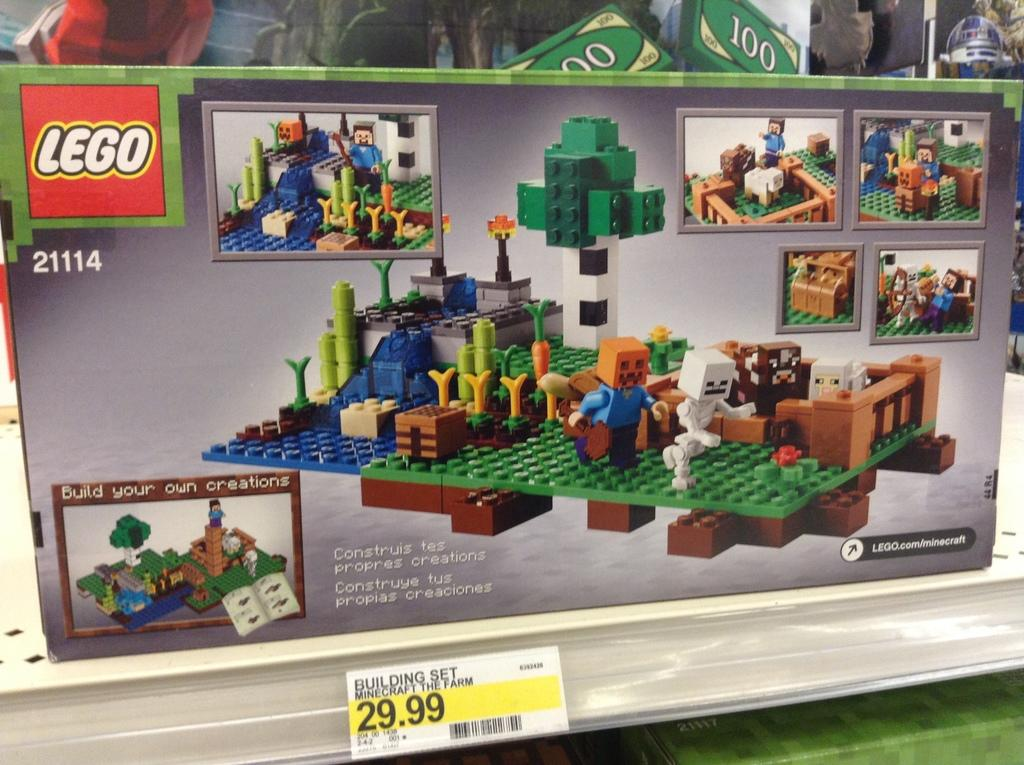What is the main subject in the center of the image? There is a building made up of lego bricks in the center of the image. What can be found at the bottom of the image? There is a bar code and some text at the bottom of the image. How does the daughter interact with the ocean in the image? There is no daughter or ocean present in the image. 